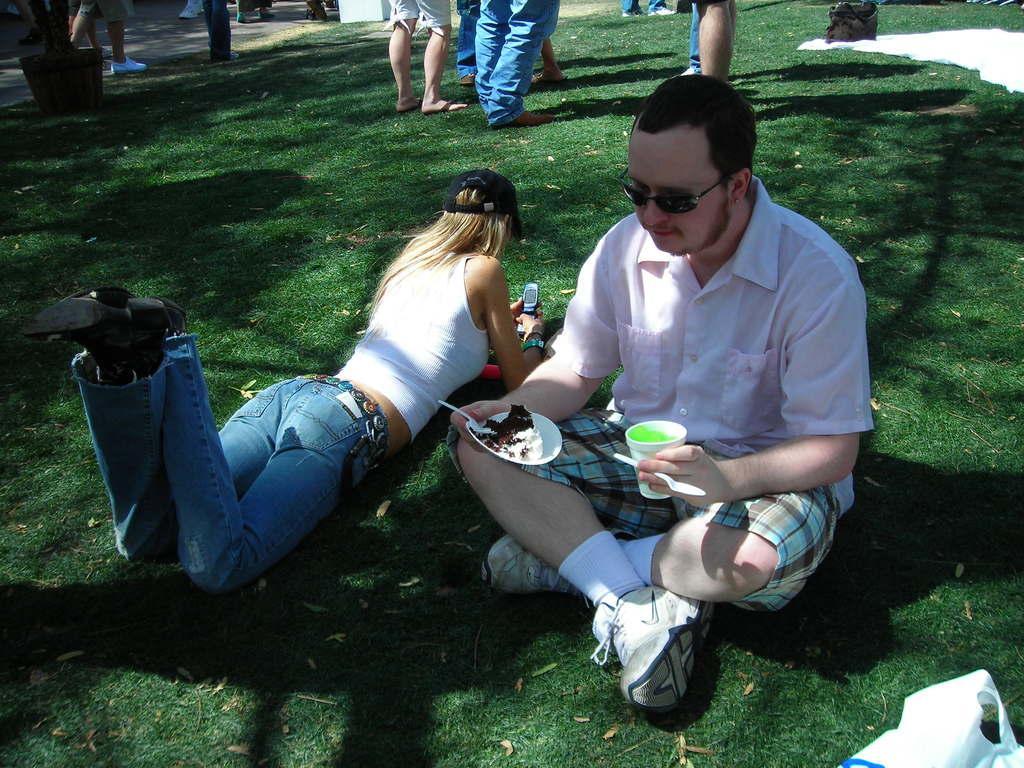Could you give a brief overview of what you see in this image? In the image there is a ground with grass. Also there are many people. One man is sitting and holding a glass with drink. Also holding a plate with spoon and food item. And he is wearing a specs. And another lady is lying on the ground. And he is wearing a cap and holding a mobile. At the top left corner there is a pot with a plant. Also there is a cover at the bottom. 